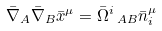Convert formula to latex. <formula><loc_0><loc_0><loc_500><loc_500>\bar { \nabla } _ { A } \bar { \nabla } _ { B } \bar { x } ^ { \mu } = \bar { \Omega } ^ { i } \, _ { A B } \bar { n } _ { i } ^ { \mu }</formula> 